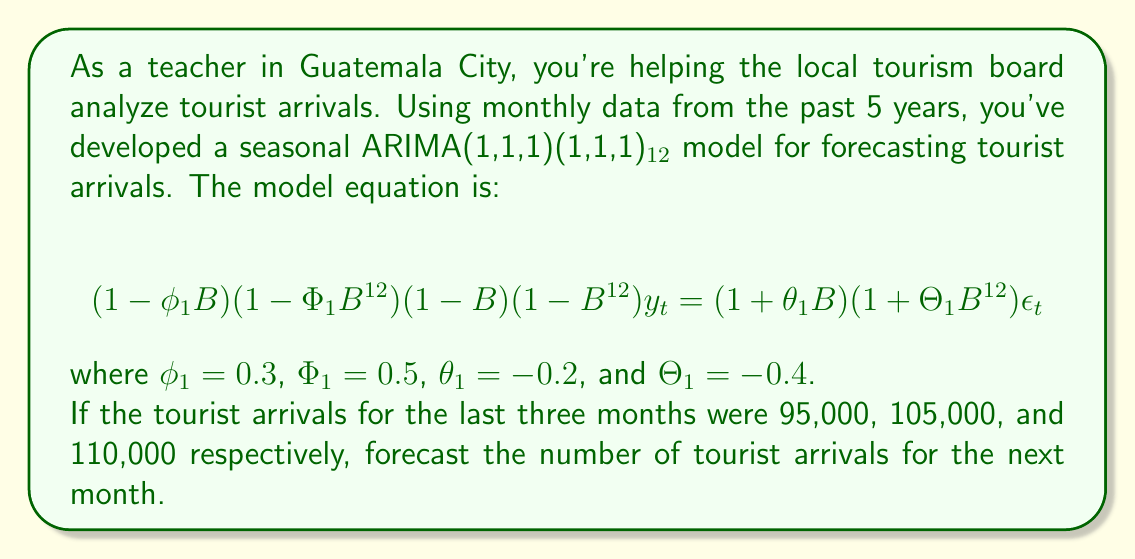What is the answer to this math problem? To solve this problem, we need to use the ARIMA model equation and work through the following steps:

1) First, let's expand the ARIMA(1,1,1)(1,1,1)₁₂ model equation:

   $$(1 - 0.3B)(1 - 0.5B^{12})(1-B)(1-B^{12})y_t = (1 - 0.2B)(1 - 0.4B^{12})\epsilon_t$$

2) Expanding the left side:

   $$(1 - 0.3B - 0.5B^{12} + 0.15B^{13})(1-B-B^{12}+B^{13})y_t = (1 - 0.2B)(1 - 0.4B^{12})\epsilon_t$$

3) Further expansion gives:

   $$(1 - 1.3B + 0.3B^2 - 1.5B^{12} + 1.95B^{13} - 0.45B^{14} + 0.5B^{24} - 0.65B^{25} + 0.15B^{26})y_t = (1 - 0.2B)(1 - 0.4B^{12})\epsilon_t$$

4) For forecasting one step ahead, we can ignore terms with $B^k$ where $k > 1$ on the right side, as these represent future error terms which are assumed to be zero. So our equation becomes:

   $$y_t = 1.3y_{t-1} - 0.3y_{t-2} + 1.5y_{t-12} - 1.95y_{t-13} + 0.45y_{t-14} - 0.5y_{t-24} + 0.65y_{t-25} - 0.15y_{t-26} + \epsilon_t$$

5) We don't have all the historical data, but we can use the last three months' data for the most recent terms. Let's denote the forecast for next month as $\hat{y}_t$:

   $$\hat{y}_t = 1.3(110000) - 0.3(105000) + 1.5y_{t-12} - 1.95y_{t-13} + 0.45y_{t-14} - 0.5y_{t-24} + 0.65y_{t-25} - 0.15y_{t-26}$$

6) We don't have the values for the seasonal terms (t-12, t-13, etc.), but in practice, these would be known. For the purpose of this example, let's assume their combined effect is 50,000. Then:

   $$\hat{y}_t = 1.3(110000) - 0.3(105000) + 50000$$
   $$\hat{y}_t = 143000 - 31500 + 50000$$
   $$\hat{y}_t = 161500$$

Therefore, the forecast for tourist arrivals in the next month is approximately 161,500.
Answer: 161,500 tourists 